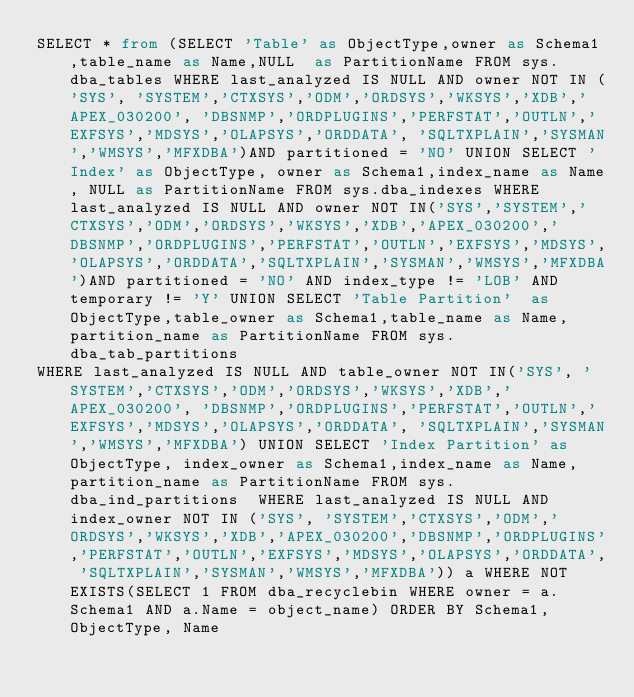<code> <loc_0><loc_0><loc_500><loc_500><_SQL_>SELECT * from (SELECT 'Table' as ObjectType,owner as Schema1,table_name as Name,NULL  as PartitionName FROM sys.dba_tables WHERE last_analyzed IS NULL AND owner NOT IN ('SYS', 'SYSTEM','CTXSYS','ODM','ORDSYS','WKSYS','XDB','APEX_030200', 'DBSNMP','ORDPLUGINS','PERFSTAT','OUTLN','EXFSYS','MDSYS','OLAPSYS','ORDDATA', 'SQLTXPLAIN','SYSMAN','WMSYS','MFXDBA')AND partitioned = 'NO' UNION SELECT 'Index' as ObjectType, owner as Schema1,index_name as Name, NULL as PartitionName FROM sys.dba_indexes WHERE last_analyzed IS NULL AND owner NOT IN('SYS','SYSTEM','CTXSYS','ODM','ORDSYS','WKSYS','XDB','APEX_030200','DBSNMP','ORDPLUGINS','PERFSTAT','OUTLN','EXFSYS','MDSYS','OLAPSYS','ORDDATA','SQLTXPLAIN','SYSMAN','WMSYS','MFXDBA')AND partitioned = 'NO' AND index_type != 'LOB' AND temporary != 'Y' UNION SELECT 'Table Partition'  as ObjectType,table_owner as Schema1,table_name as Name, partition_name as PartitionName FROM sys.dba_tab_partitions 
WHERE last_analyzed IS NULL AND table_owner NOT IN('SYS', 'SYSTEM','CTXSYS','ODM','ORDSYS','WKSYS','XDB','APEX_030200', 'DBSNMP','ORDPLUGINS','PERFSTAT','OUTLN','EXFSYS','MDSYS','OLAPSYS','ORDDATA', 'SQLTXPLAIN','SYSMAN','WMSYS','MFXDBA') UNION SELECT 'Index Partition' as ObjectType, index_owner as Schema1,index_name as Name,partition_name as PartitionName FROM sys.dba_ind_partitions  WHERE last_analyzed IS NULL AND index_owner NOT IN ('SYS', 'SYSTEM','CTXSYS','ODM','ORDSYS','WKSYS','XDB','APEX_030200','DBSNMP','ORDPLUGINS','PERFSTAT','OUTLN','EXFSYS','MDSYS','OLAPSYS','ORDDATA', 'SQLTXPLAIN','SYSMAN','WMSYS','MFXDBA')) a WHERE NOT EXISTS(SELECT 1 FROM dba_recyclebin WHERE owner = a.Schema1 AND a.Name = object_name) ORDER BY Schema1, ObjectType, Name
                </code> 